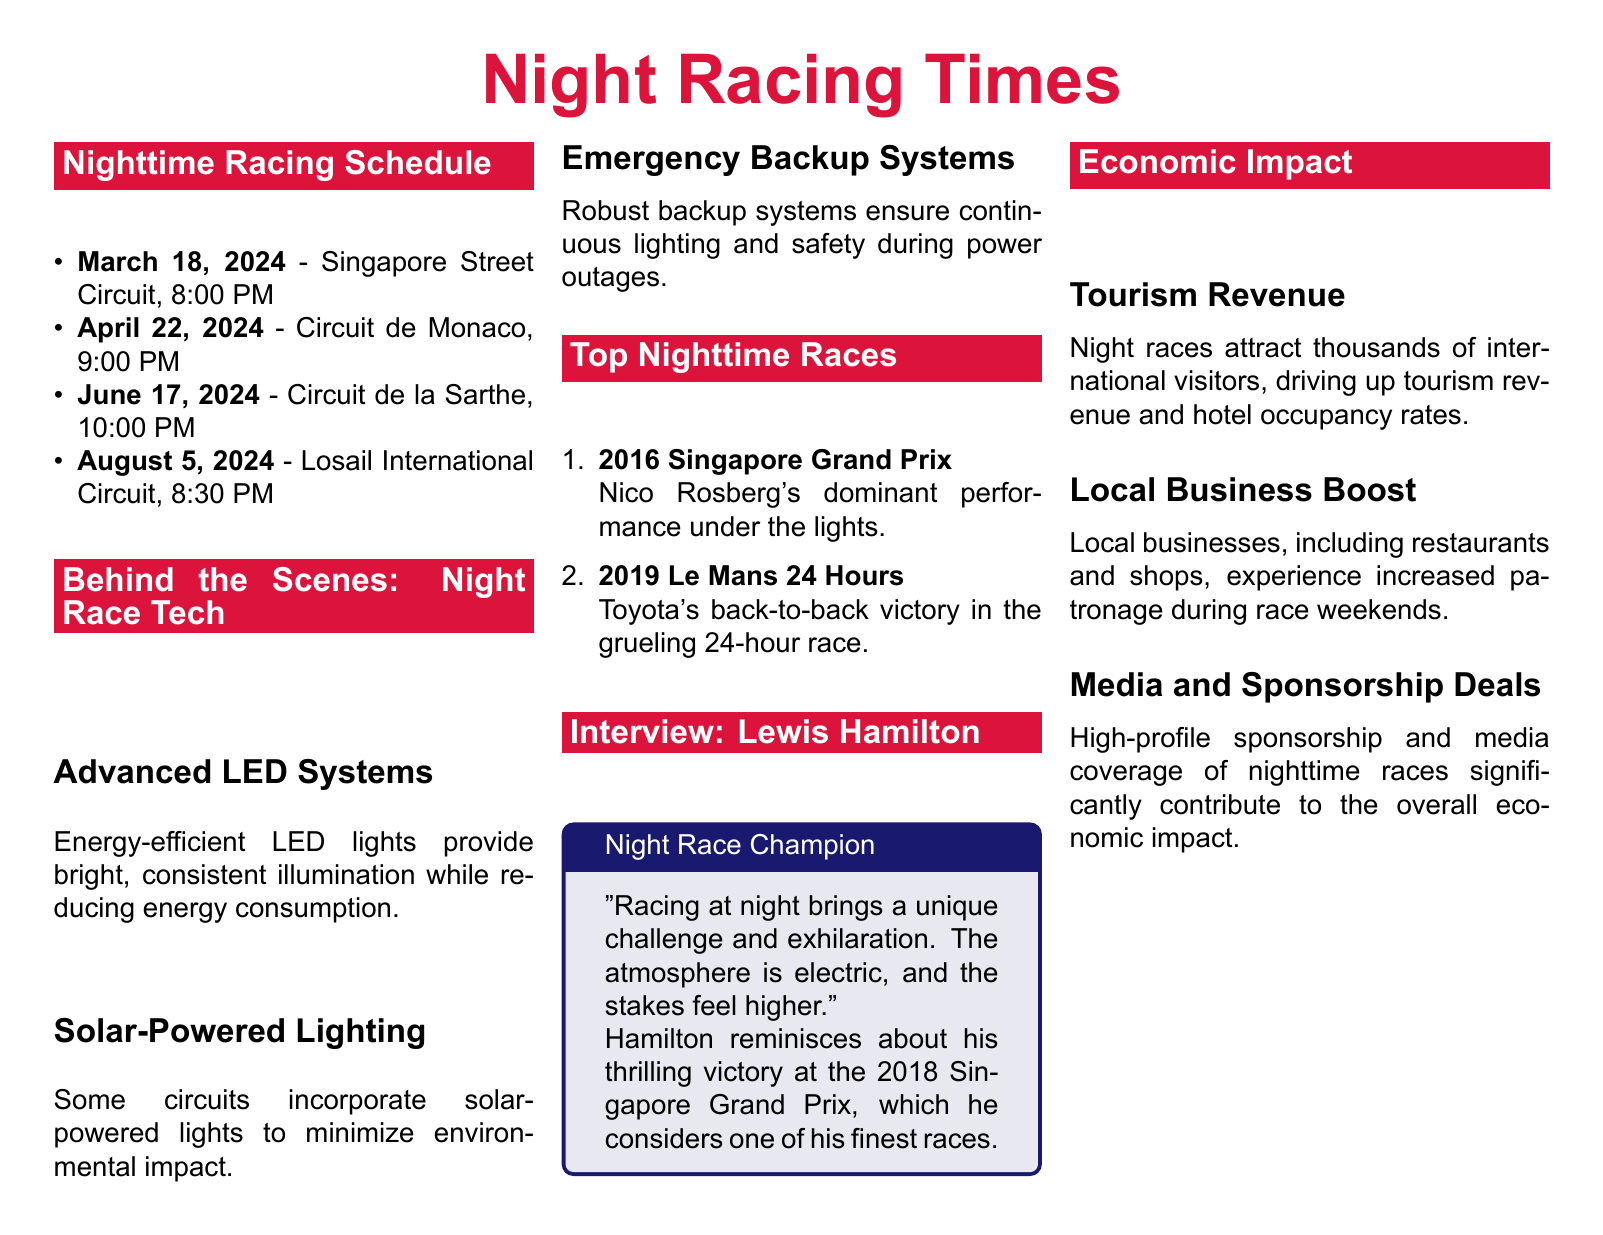What is the date of the Singapore Street Circuit race? The document states the race date for the Singapore Street Circuit as March 18, 2024.
Answer: March 18, 2024 What time does the Circuit de Monaco race start? According to the schedule, the Circuit de Monaco race starts at 9:00 PM.
Answer: 9:00 PM Which technology minimizes environmental impact during nighttime races? The document mentions solar-powered lighting as a technology that minimizes environmental impact.
Answer: Solar-powered lighting Who won the 2019 Le Mans 24 Hours? The document notes that Toyota's team won the 2019 Le Mans 24 Hours.
Answer: Toyota What unique challenge does Lewis Hamilton associate with night racing? Hamilton describes the atmosphere as electric, indicating a unique challenge in night racing.
Answer: Electric How many nighttime races are listed in the comprehensive guide? The document lists four nighttime races in the schedule.
Answer: Four Which driver is featured in the interview section? The interview section features Lewis Hamilton as the highlighted driver.
Answer: Lewis Hamilton What is one of the economic benefits of nighttime races mentioned in the document? The document lists tourism revenue as one of the economic benefits of nighttime races.
Answer: Tourism revenue 